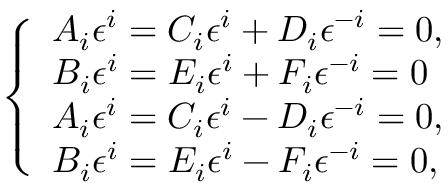Convert formula to latex. <formula><loc_0><loc_0><loc_500><loc_500>\left \{ \begin{array} { l l } { A _ { i } \epsilon ^ { i } = C _ { i } \epsilon ^ { i } + D _ { i } \epsilon ^ { - i } = 0 , } & \\ { B _ { i } \epsilon ^ { i } = E _ { i } \epsilon ^ { i } + F _ { i } \epsilon ^ { - i } = 0 } & \\ { A _ { i } \epsilon ^ { i } = C _ { i } \epsilon ^ { i } - D _ { i } \epsilon ^ { - i } = 0 , } & \\ { B _ { i } \epsilon ^ { i } = E _ { i } \epsilon ^ { i } - F _ { i } \epsilon ^ { - i } = 0 , } & \end{array}</formula> 